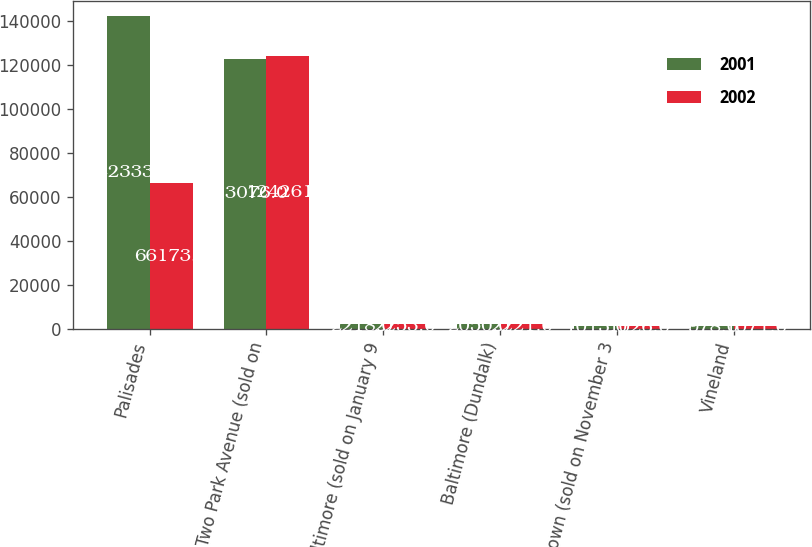Convert chart to OTSL. <chart><loc_0><loc_0><loc_500><loc_500><stacked_bar_chart><ecel><fcel>Palisades<fcel>Two Park Avenue (sold on<fcel>Baltimore (sold on January 9<fcel>Baltimore (Dundalk)<fcel>Hagerstown (sold on November 3<fcel>Vineland<nl><fcel>2001<fcel>142333<fcel>123076<fcel>2218<fcel>2050<fcel>1013<fcel>978<nl><fcel>2002<fcel>66173<fcel>124261<fcel>2253<fcel>2221<fcel>1026<fcel>1071<nl></chart> 